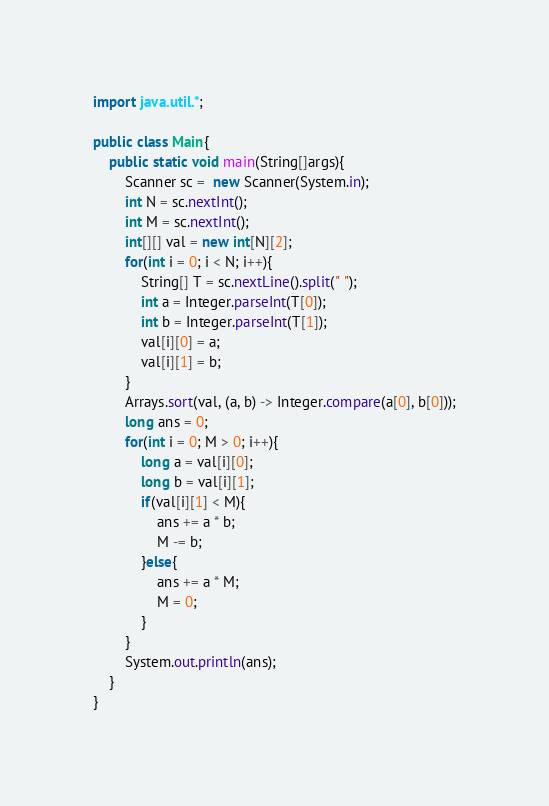Convert code to text. <code><loc_0><loc_0><loc_500><loc_500><_Java_>import java.util.*;

public class Main{
    public static void main(String[]args){
        Scanner sc =  new Scanner(System.in);
        int N = sc.nextInt();
        int M = sc.nextInt();
        int[][] val = new int[N][2];
        for(int i = 0; i < N; i++){
            String[] T = sc.nextLine().split(" ");
            int a = Integer.parseInt(T[0]);
            int b = Integer.parseInt(T[1]);
            val[i][0] = a;
            val[i][1] = b;
        }
        Arrays.sort(val, (a, b) -> Integer.compare(a[0], b[0]));
        long ans = 0;
        for(int i = 0; M > 0; i++){
            long a = val[i][0];
            long b = val[i][1];
            if(val[i][1] < M){
                ans += a * b;
                M -= b;
            }else{
                ans += a * M;
                M = 0;
            }
        }
        System.out.println(ans);
    }
}</code> 